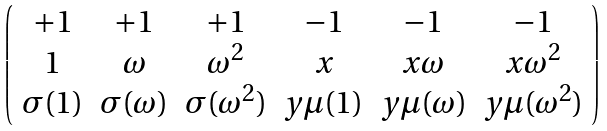Convert formula to latex. <formula><loc_0><loc_0><loc_500><loc_500>\left ( \begin{array} { c c c c c c } + 1 & + 1 & + 1 & - 1 & - 1 & - 1 \\ 1 & \omega & \omega ^ { 2 } & x & x \omega & x \omega ^ { 2 } \\ \sigma ( 1 ) & \sigma ( \omega ) & \sigma ( \omega ^ { 2 } ) & y \mu ( 1 ) & y \mu ( \omega ) & y \mu ( \omega ^ { 2 } ) \\ \end{array} \right )</formula> 